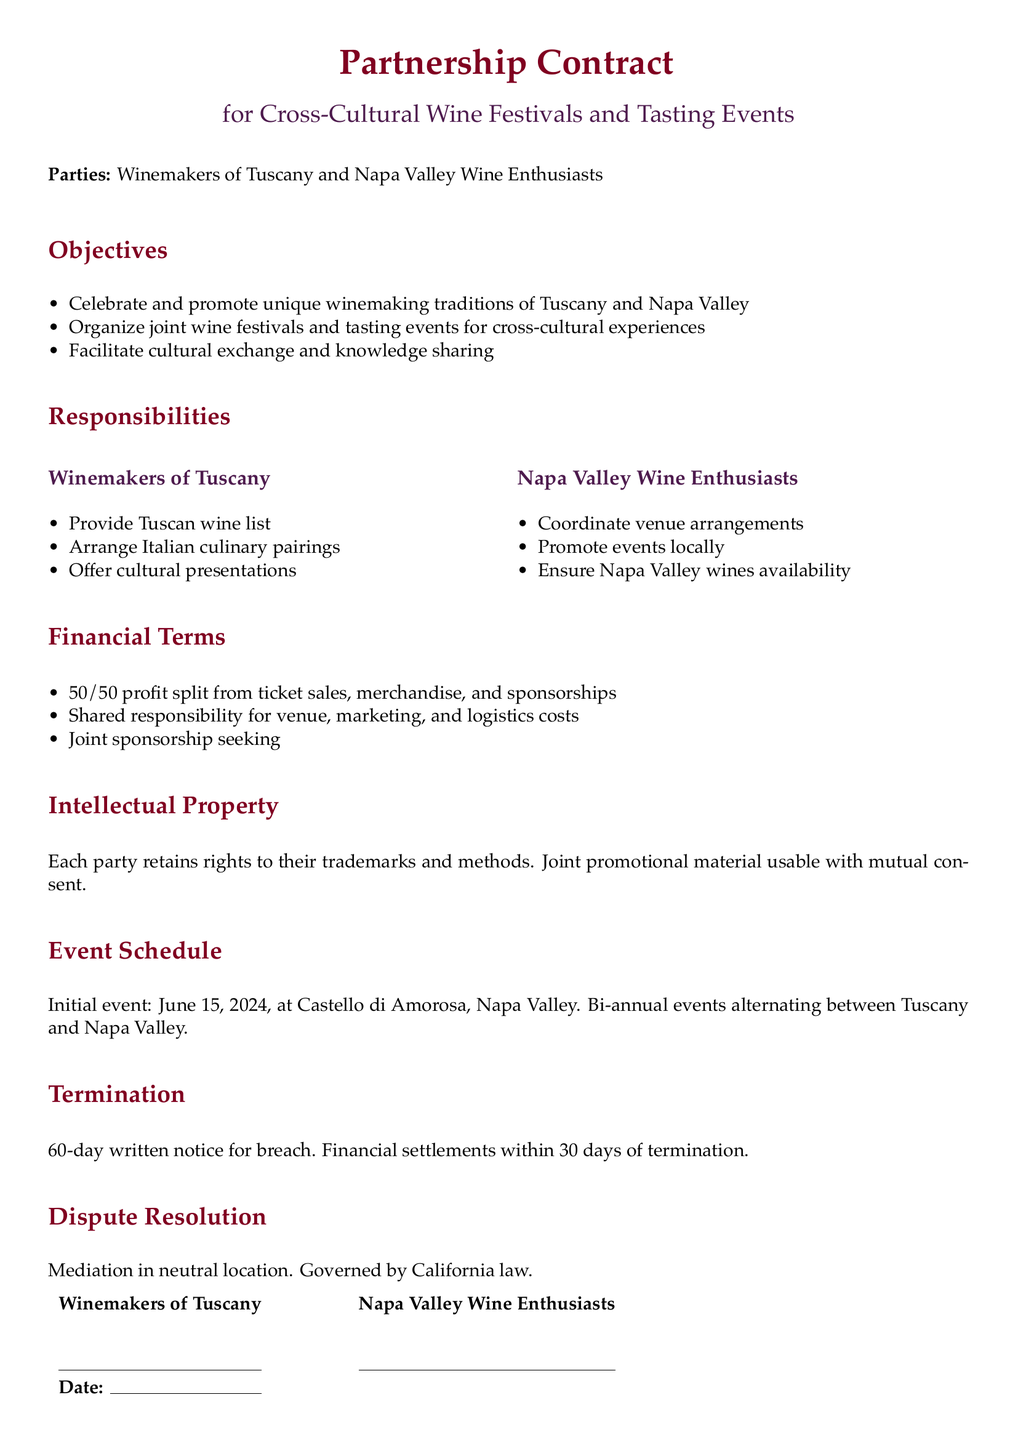What are the names of the parties involved? The names of the parties are clearly stated at the beginning of the document, identifying them as Winemakers of Tuscany and Napa Valley Wine Enthusiasts.
Answer: Winemakers of Tuscany and Napa Valley Wine Enthusiasts What is the profit split percentage from ticket sales? The financial terms section specifies the profit split from ticket sales, stating it is a 50/50 split.
Answer: 50/50 When is the initial event scheduled? The event schedule section lists the date of the initial event, which is June 15, 2024.
Answer: June 15, 2024 What responsibilities do the Napa Valley Wine Enthusiasts have? The responsibilities section describes specific tasks assigned to Napa Valley Wine Enthusiasts, which includes coordinating venue arrangements and promoting events locally.
Answer: Coordinate venue arrangements, promote events locally, ensure Napa Valley wines availability What is the duration of the notice required for termination? The termination section details how much notice must be provided for termination due to breach, which is 60 days.
Answer: 60 days What is the governing law stated in the document? The dispute resolution section mentions that the contract is governed by California law.
Answer: California law What kind of cultural experiences do the parties aim to organize? The objectives section highlights the aim to organize joint wine festivals and tasting events for cross-cultural experiences.
Answer: Cross-cultural experiences What type of dispute resolution is specified? The dispute resolution section specifies that mediation will be used in a neutral location for resolving disputes.
Answer: Mediation in a neutral location 